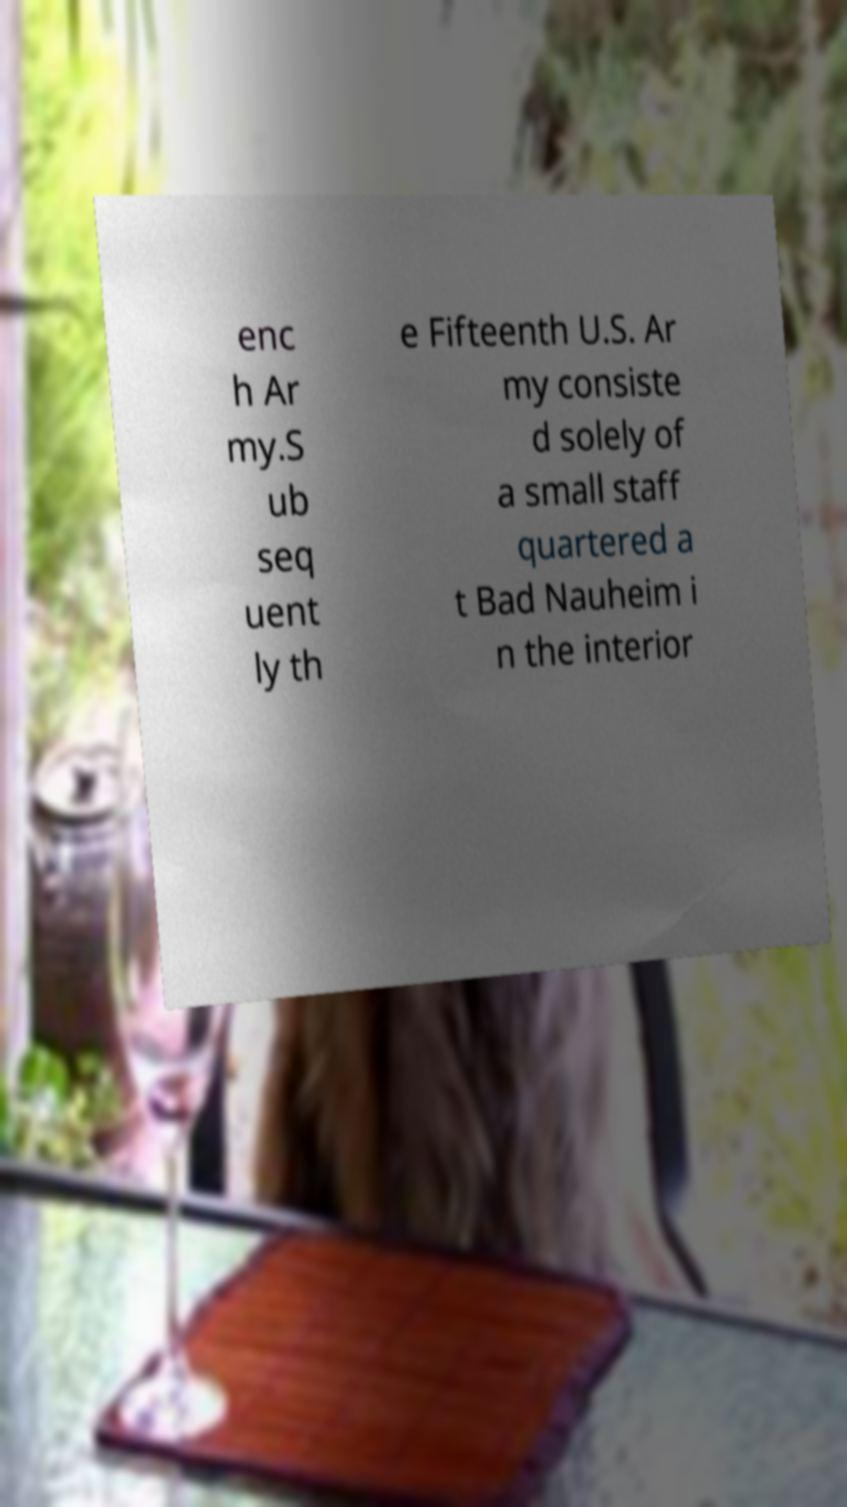Please identify and transcribe the text found in this image. enc h Ar my.S ub seq uent ly th e Fifteenth U.S. Ar my consiste d solely of a small staff quartered a t Bad Nauheim i n the interior 